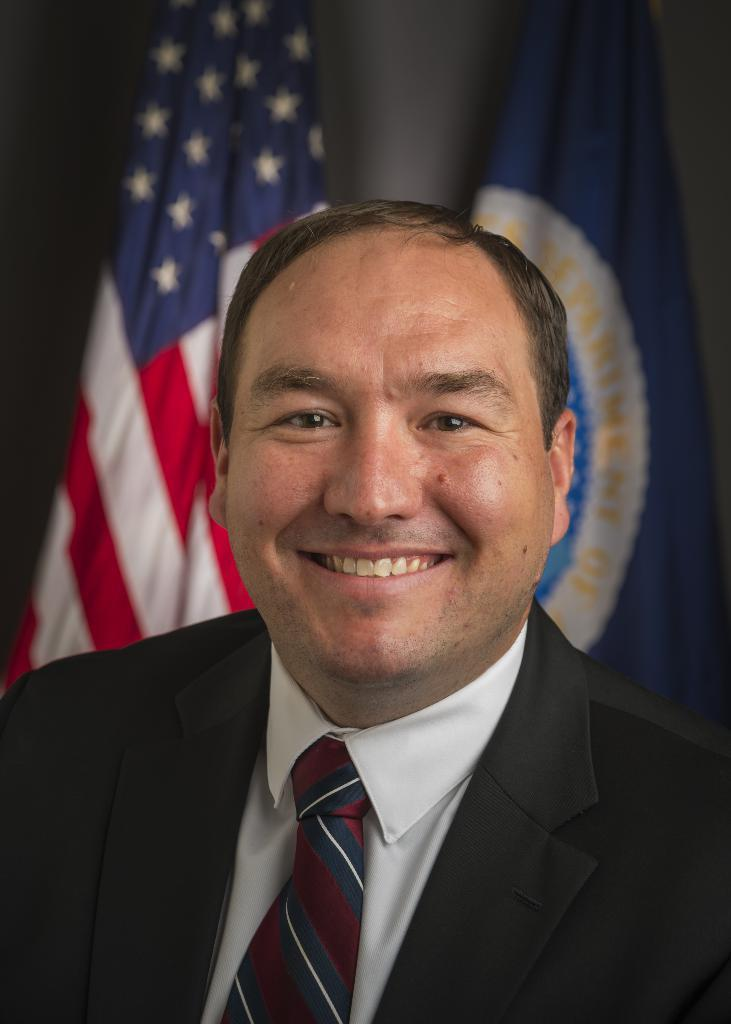What is the main subject of the image? There is a person in the image. What is the person wearing? The person is wearing a black color blazer. What is the person's facial expression? The person is smiling. What can be seen in the background of the image? There are two flags in the background of the image. What type of quilt is being used as a prop in the image? There is no quilt present in the image. Can you hear the drum being played in the background of the image? There is no drum or sound present in the image. 